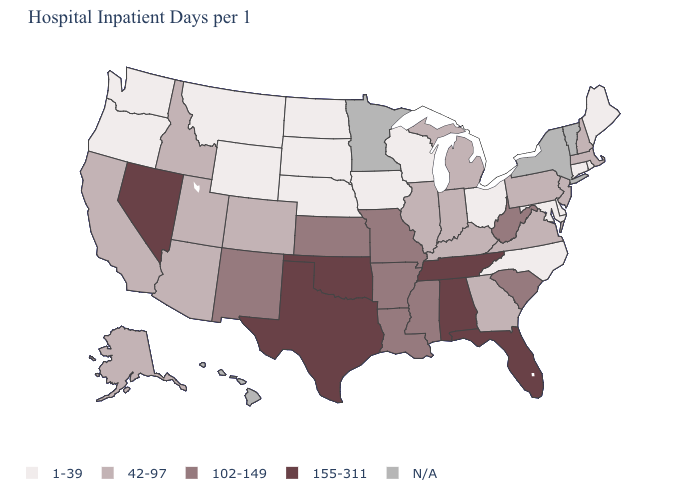What is the value of Missouri?
Answer briefly. 102-149. Name the states that have a value in the range 102-149?
Give a very brief answer. Arkansas, Kansas, Louisiana, Mississippi, Missouri, New Mexico, South Carolina, West Virginia. What is the value of North Dakota?
Quick response, please. 1-39. Is the legend a continuous bar?
Keep it brief. No. What is the value of Arizona?
Answer briefly. 42-97. Name the states that have a value in the range 42-97?
Be succinct. Alaska, Arizona, California, Colorado, Georgia, Idaho, Illinois, Indiana, Kentucky, Massachusetts, Michigan, New Hampshire, New Jersey, Pennsylvania, Utah, Virginia. Does Maryland have the lowest value in the South?
Be succinct. Yes. Name the states that have a value in the range N/A?
Give a very brief answer. Hawaii, Minnesota, New York, Vermont. What is the value of South Carolina?
Give a very brief answer. 102-149. Which states have the lowest value in the MidWest?
Write a very short answer. Iowa, Nebraska, North Dakota, Ohio, South Dakota, Wisconsin. What is the lowest value in states that border Minnesota?
Give a very brief answer. 1-39. Is the legend a continuous bar?
Answer briefly. No. Which states have the highest value in the USA?
Give a very brief answer. Alabama, Florida, Nevada, Oklahoma, Tennessee, Texas. What is the value of Michigan?
Short answer required. 42-97. Which states have the lowest value in the USA?
Short answer required. Connecticut, Delaware, Iowa, Maine, Maryland, Montana, Nebraska, North Carolina, North Dakota, Ohio, Oregon, Rhode Island, South Dakota, Washington, Wisconsin, Wyoming. 